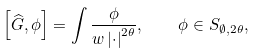<formula> <loc_0><loc_0><loc_500><loc_500>\left [ \widehat { G } , \phi \right ] = \int \frac { \phi } { w \left | \cdot \right | ^ { 2 \theta } } , \quad \phi \in S _ { \emptyset , 2 \theta } ,</formula> 